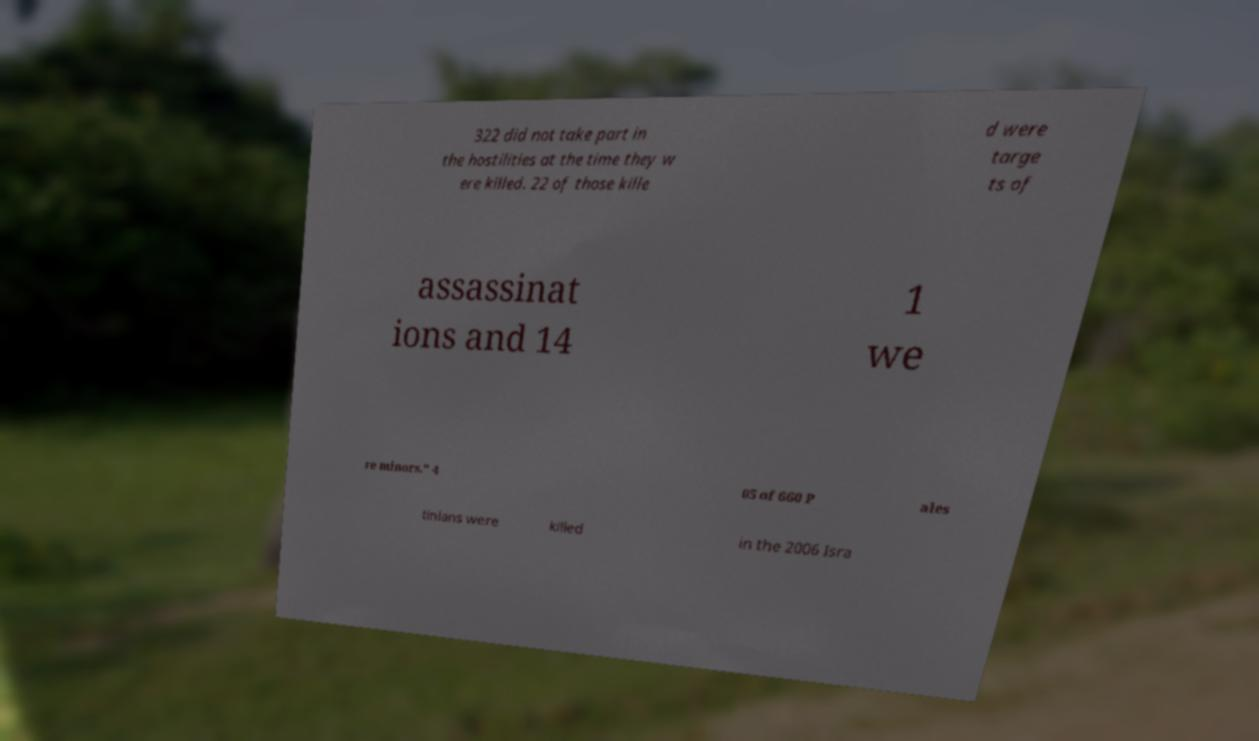What messages or text are displayed in this image? I need them in a readable, typed format. 322 did not take part in the hostilities at the time they w ere killed. 22 of those kille d were targe ts of assassinat ions and 14 1 we re minors." 4 05 of 660 P ales tinians were killed in the 2006 Isra 